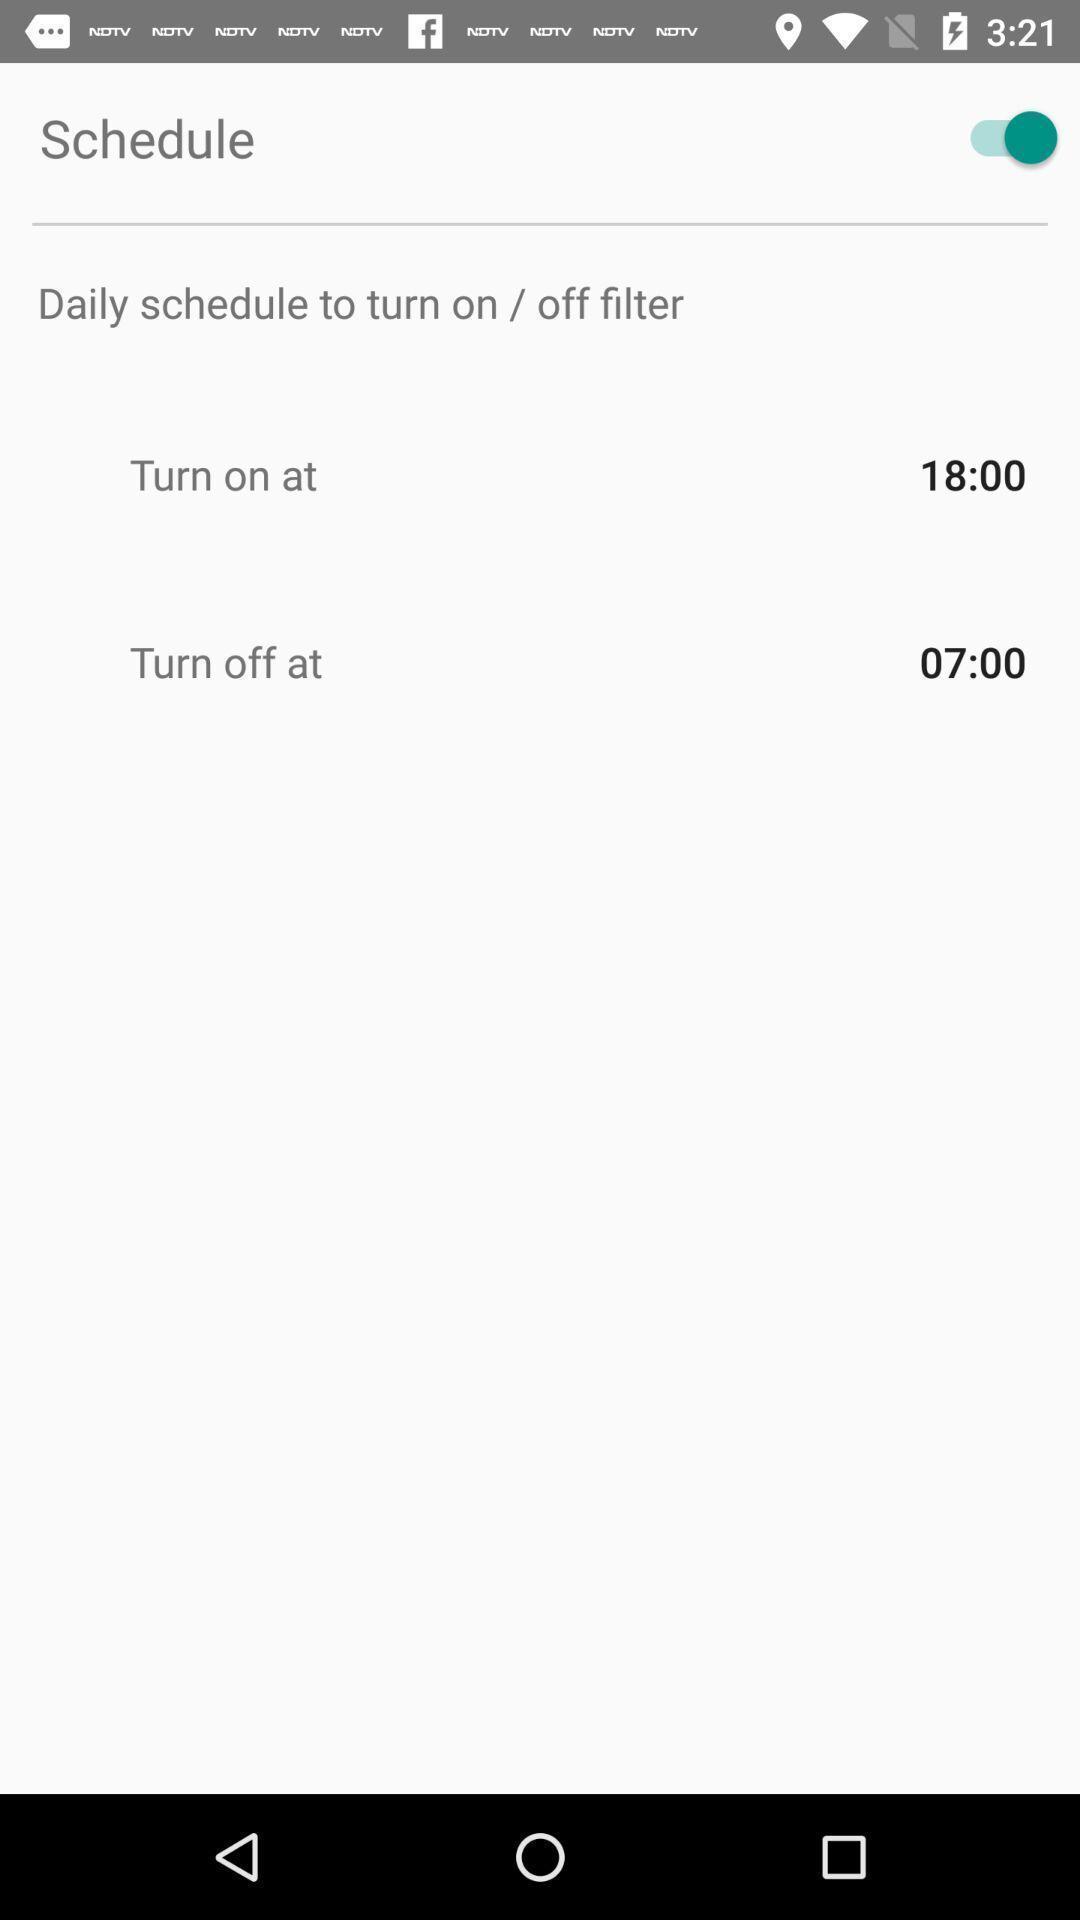Provide a textual representation of this image. Page displaying with the schedule settings in application. 